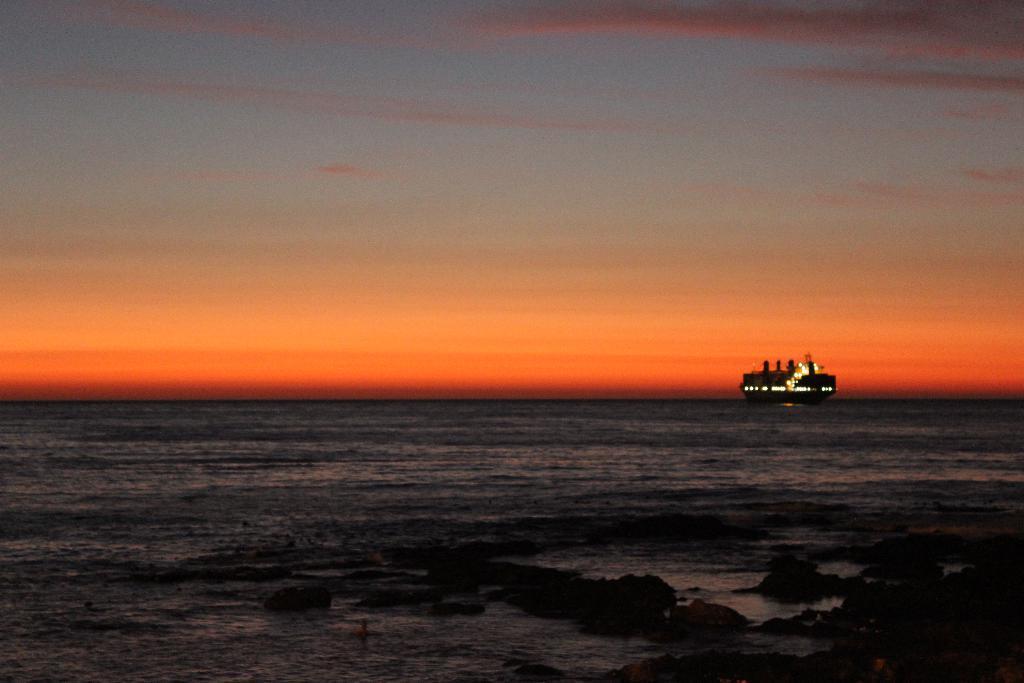Describe this image in one or two sentences. In this image, there is a sea and at the top there is a sky. 